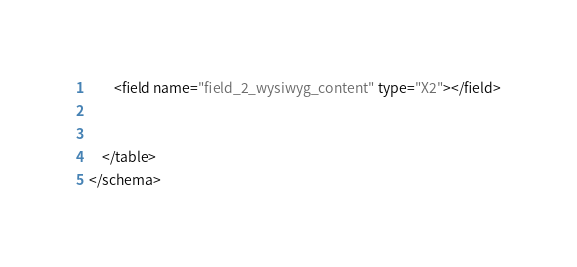<code> <loc_0><loc_0><loc_500><loc_500><_XML_>
		<field name="field_2_wysiwyg_content" type="X2"></field>


	</table>
</schema></code> 